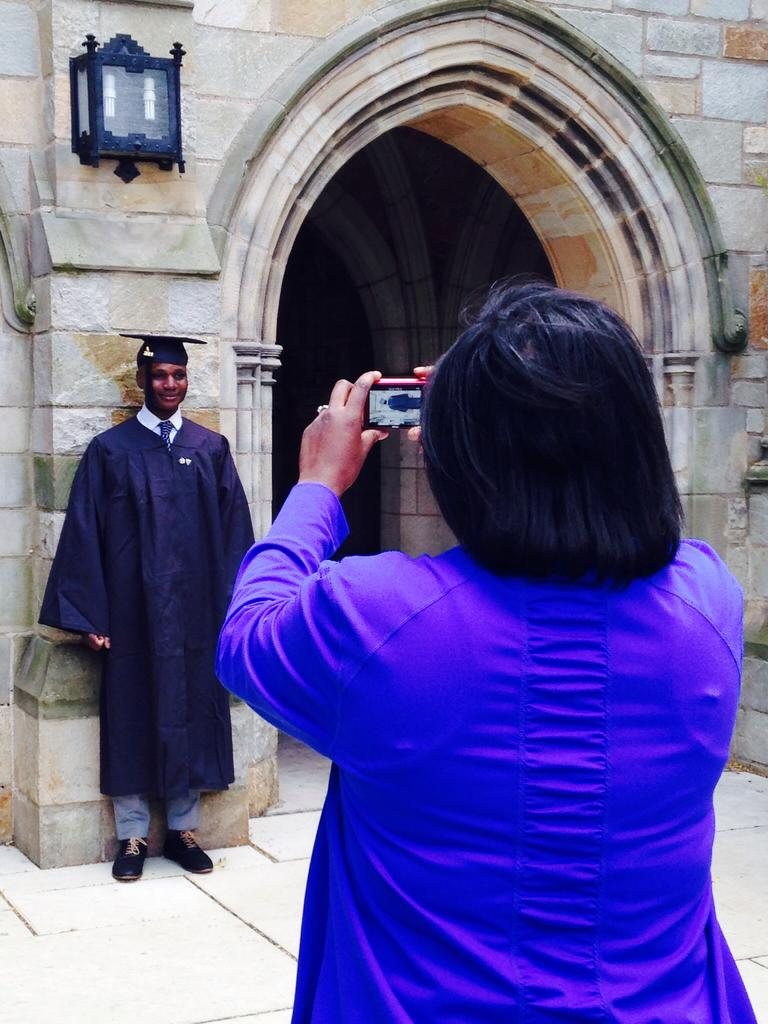How many people are in the image? There are two persons in the image. What is one of the persons doing in the image? A lady is taking a picture with a camera. What can be seen in the background of the image? There is a light and a wall in the background of the image. How many horses are visible in the image? There are no horses present in the image. What type of canvas is being used by the lady to take the picture? The lady is using a camera to take the picture, not a canvas. 